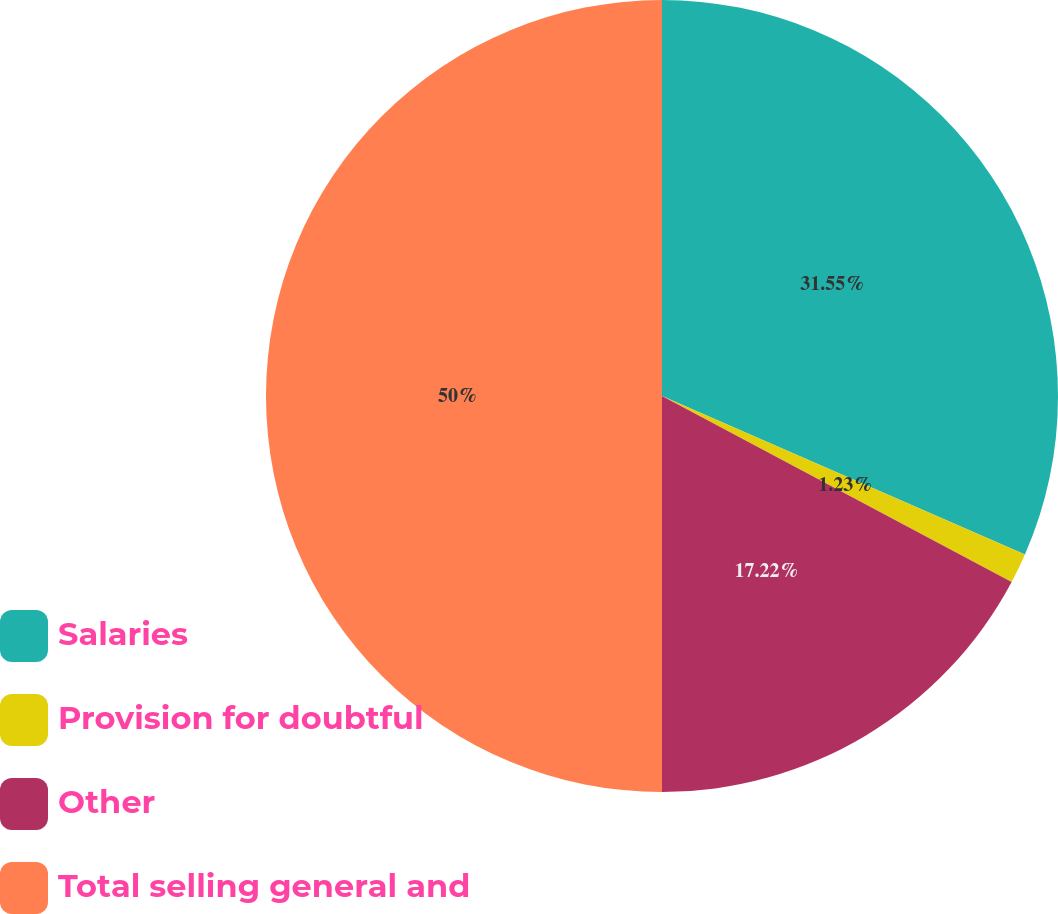Convert chart. <chart><loc_0><loc_0><loc_500><loc_500><pie_chart><fcel>Salaries<fcel>Provision for doubtful<fcel>Other<fcel>Total selling general and<nl><fcel>31.55%<fcel>1.23%<fcel>17.22%<fcel>50.0%<nl></chart> 